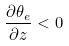Convert formula to latex. <formula><loc_0><loc_0><loc_500><loc_500>\frac { \partial \theta _ { e } } { \partial z } < 0</formula> 